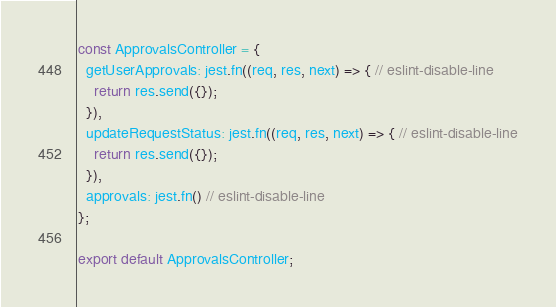Convert code to text. <code><loc_0><loc_0><loc_500><loc_500><_JavaScript_>const ApprovalsController = {
  getUserApprovals: jest.fn((req, res, next) => { // eslint-disable-line
    return res.send({});
  }),
  updateRequestStatus: jest.fn((req, res, next) => { // eslint-disable-line
    return res.send({});
  }),
  approvals: jest.fn() // eslint-disable-line
};

export default ApprovalsController;
</code> 